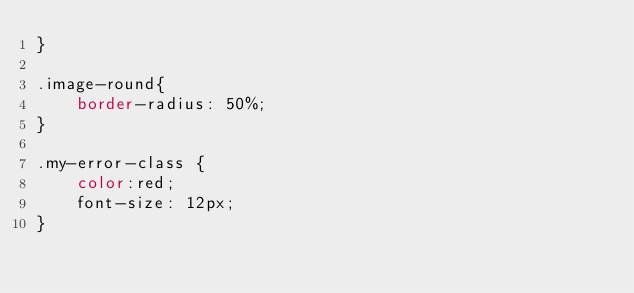<code> <loc_0><loc_0><loc_500><loc_500><_CSS_>}

.image-round{
    border-radius: 50%;
}

.my-error-class {
    color:red;
    font-size: 12px;
}
</code> 